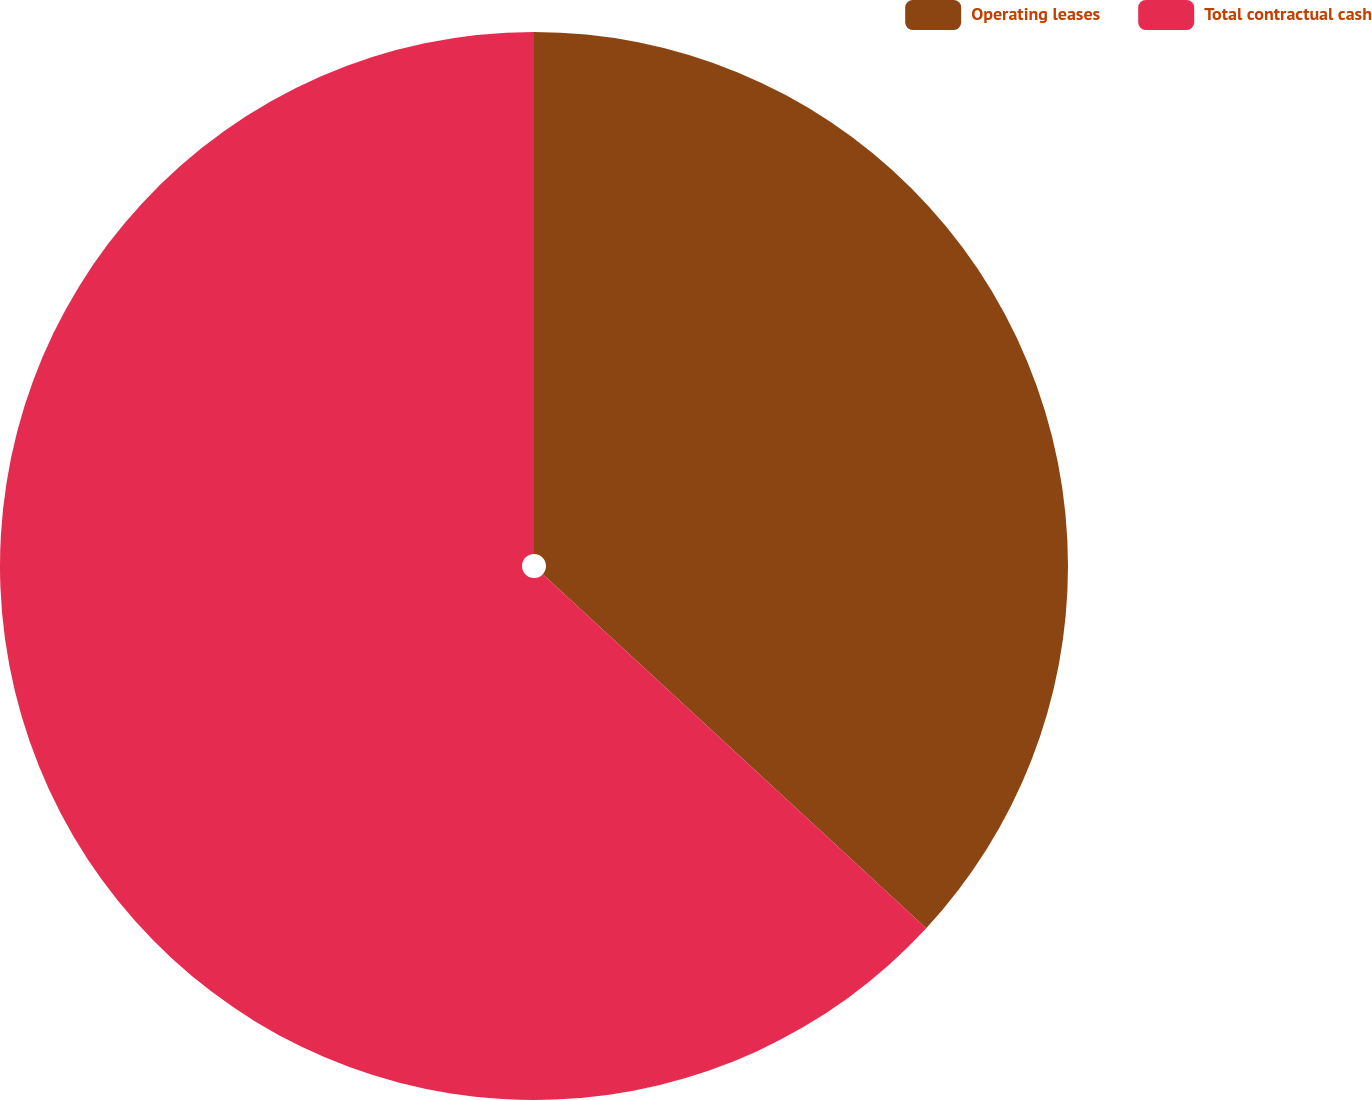Convert chart to OTSL. <chart><loc_0><loc_0><loc_500><loc_500><pie_chart><fcel>Operating leases<fcel>Total contractual cash<nl><fcel>36.87%<fcel>63.13%<nl></chart> 